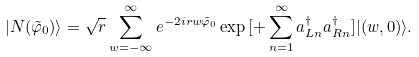<formula> <loc_0><loc_0><loc_500><loc_500>| N ( \tilde { \varphi } _ { 0 } ) \rangle = \sqrt { r } \sum _ { w = - \infty } ^ { \infty } e ^ { - 2 i r w \tilde { \varphi } _ { 0 } } \exp { [ + \sum _ { n = 1 } ^ { \infty } a ^ { \dagger } _ { L n } a ^ { \dagger } _ { R n } ] } | ( w , 0 ) \rangle .</formula> 